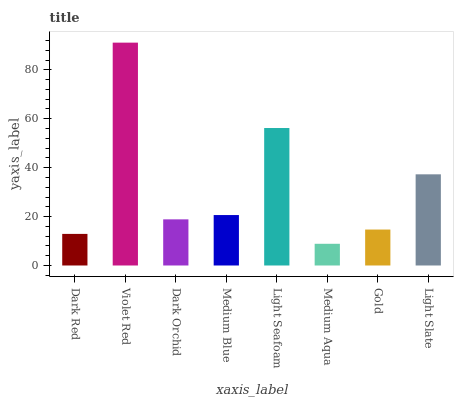Is Medium Aqua the minimum?
Answer yes or no. Yes. Is Violet Red the maximum?
Answer yes or no. Yes. Is Dark Orchid the minimum?
Answer yes or no. No. Is Dark Orchid the maximum?
Answer yes or no. No. Is Violet Red greater than Dark Orchid?
Answer yes or no. Yes. Is Dark Orchid less than Violet Red?
Answer yes or no. Yes. Is Dark Orchid greater than Violet Red?
Answer yes or no. No. Is Violet Red less than Dark Orchid?
Answer yes or no. No. Is Medium Blue the high median?
Answer yes or no. Yes. Is Dark Orchid the low median?
Answer yes or no. Yes. Is Gold the high median?
Answer yes or no. No. Is Dark Red the low median?
Answer yes or no. No. 